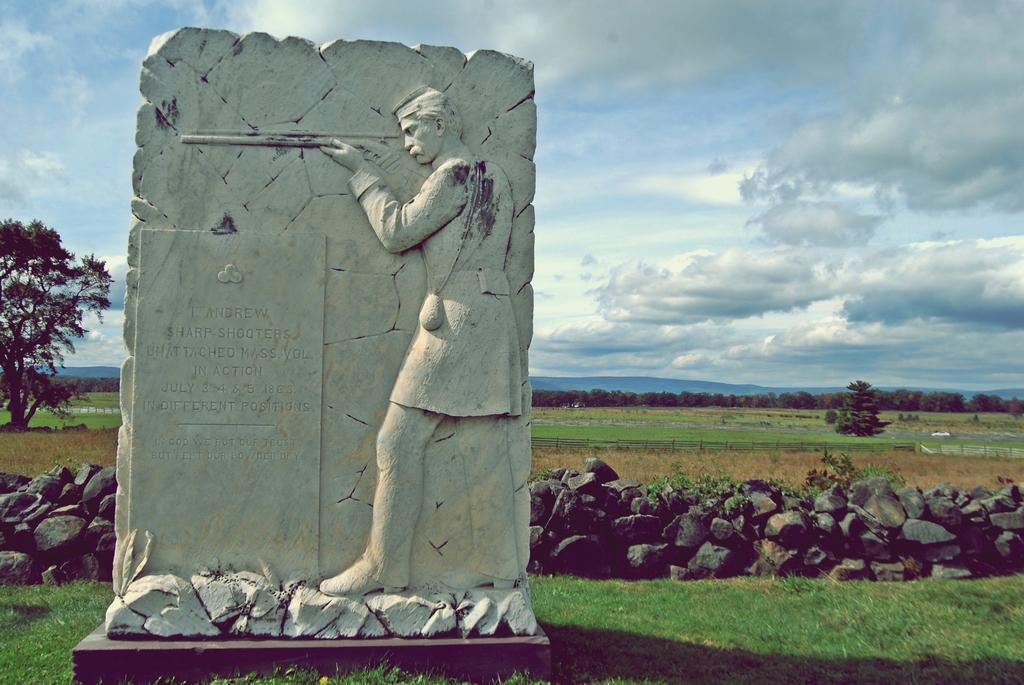What can be found on the path in the image? There is a stone sculpture on the path. What is located behind the sculpture? There are stones and trees visible behind the sculpture. What can be seen in the distance behind the trees? There are hills visible in the background. How would you describe the sky in the image? The sky is cloudy. What type of letter is being delivered by the sail in the image? There is no sail or letter present in the image; it features a stone sculpture on a path with stones, trees, hills, and a cloudy sky. 